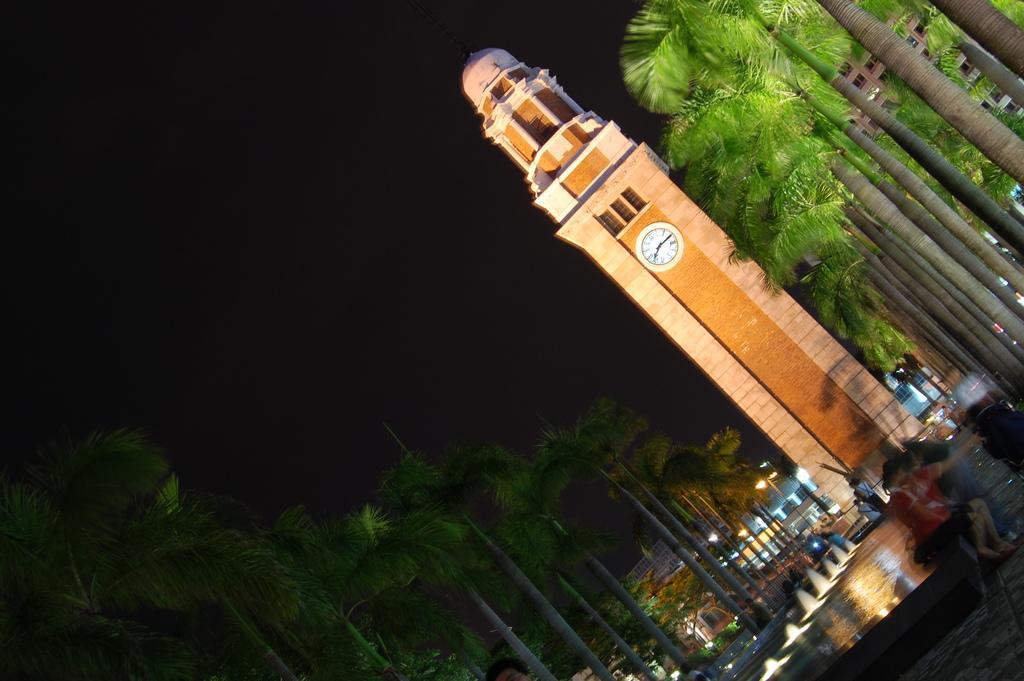In one or two sentences, can you explain what this image depicts? In this image there is a big clock tower behind that there is a building also there is a road in front of the road where so many people are standing and trees beside the road. 